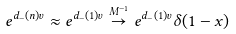<formula> <loc_0><loc_0><loc_500><loc_500>e ^ { d _ { - } ( n ) v } \approx e ^ { d _ { - } ( 1 ) v } \stackrel { M ^ { - 1 } } { \to } e ^ { d _ { - } ( 1 ) v } \delta ( 1 - x )</formula> 